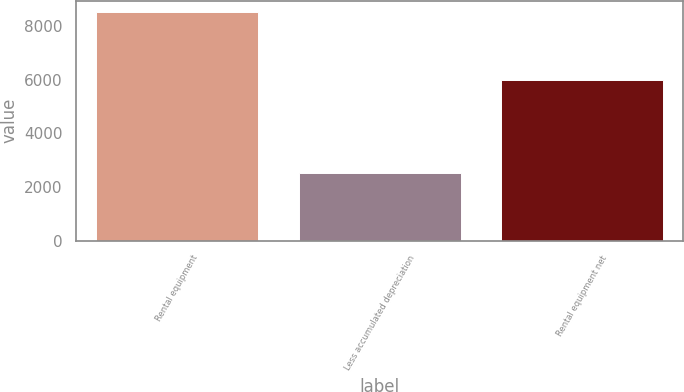Convert chart to OTSL. <chart><loc_0><loc_0><loc_500><loc_500><bar_chart><fcel>Rental equipment<fcel>Less accumulated depreciation<fcel>Rental equipment net<nl><fcel>8527<fcel>2519<fcel>6008<nl></chart> 